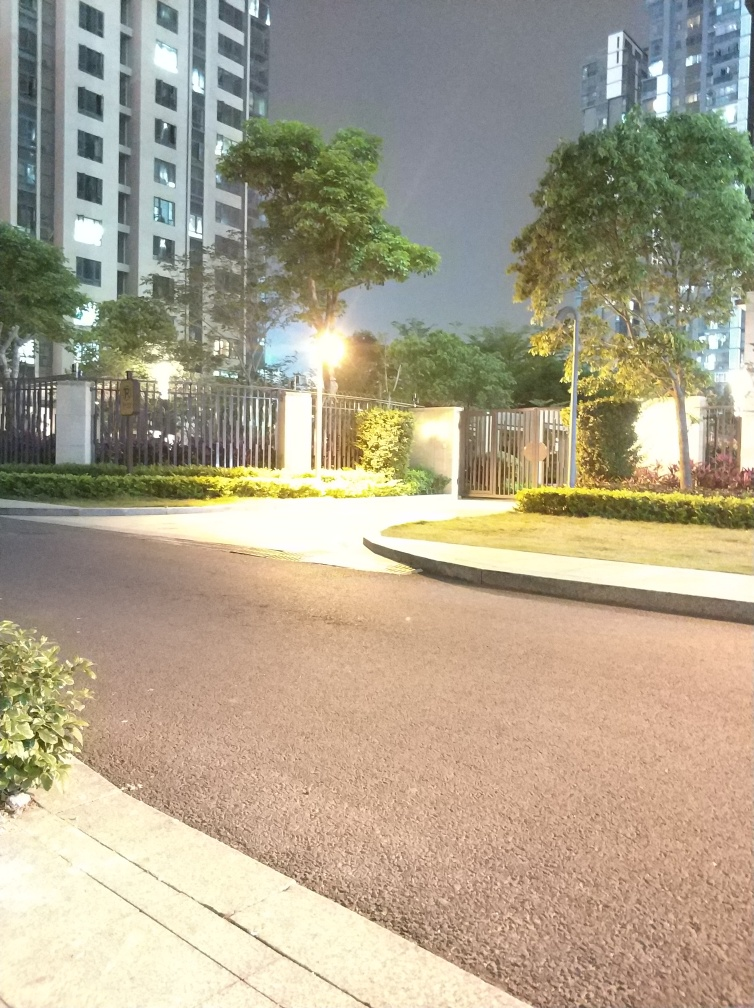Are there any quality issues with this image? Yes, the image seems to be overexposed due to the intensity of the light sources, which results in a loss of detail in the brightly lit areas, particularly around the street lamp and the building entrance. Furthermore, there is visible graininess and noise in the darker areas, suggesting the image was taken with a high ISO setting or in low-light conditions without sufficient stabilization. 